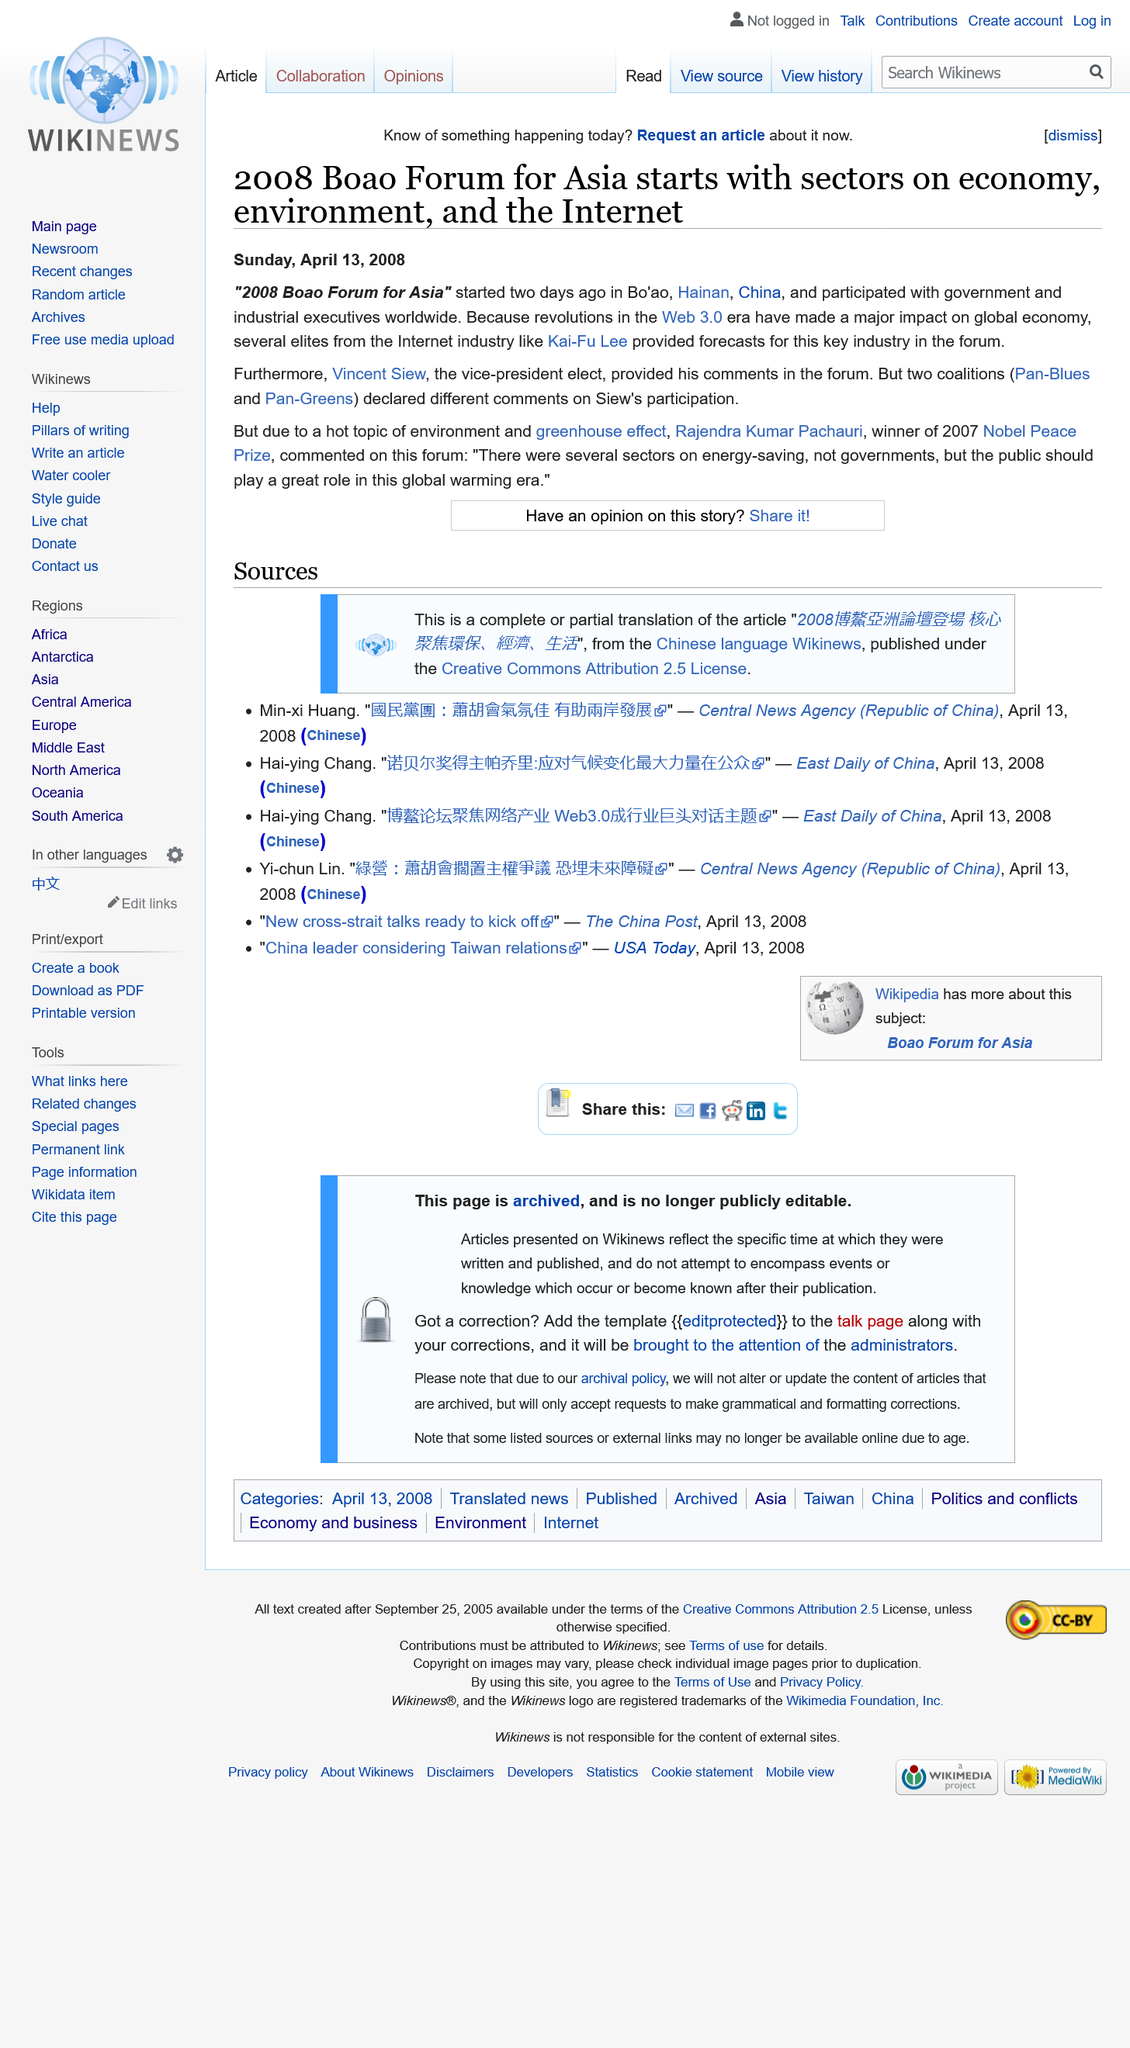List a handful of essential elements in this visual. The article reporting on the 2008 Boao Forum for Asia was published on Sunday, April 13, 2008. The 2008 Boao Forum for Asia is being held in Bo'ao, Hainan, China. Rajendra Kumar Pachauri was the winner of the 2007 Nobel Peace Prize. 